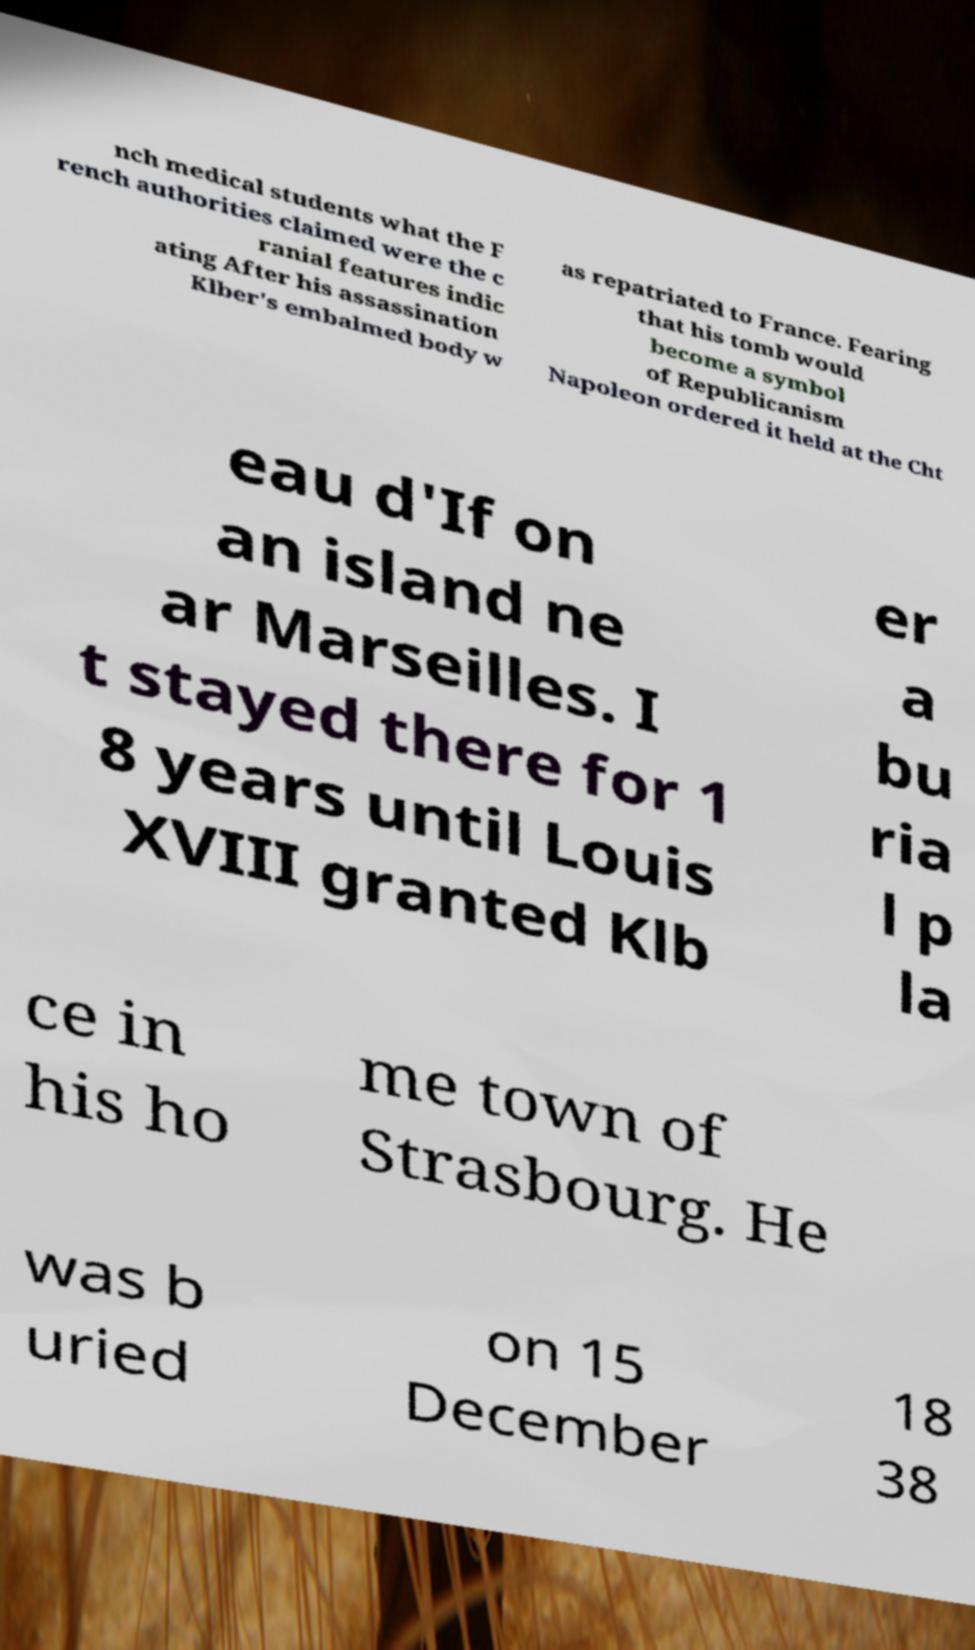What messages or text are displayed in this image? I need them in a readable, typed format. nch medical students what the F rench authorities claimed were the c ranial features indic ating After his assassination Klber's embalmed body w as repatriated to France. Fearing that his tomb would become a symbol of Republicanism Napoleon ordered it held at the Cht eau d'If on an island ne ar Marseilles. I t stayed there for 1 8 years until Louis XVIII granted Klb er a bu ria l p la ce in his ho me town of Strasbourg. He was b uried on 15 December 18 38 